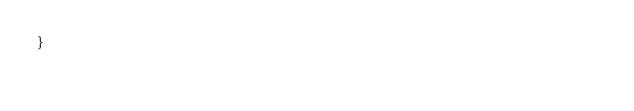<code> <loc_0><loc_0><loc_500><loc_500><_C_>}
</code> 